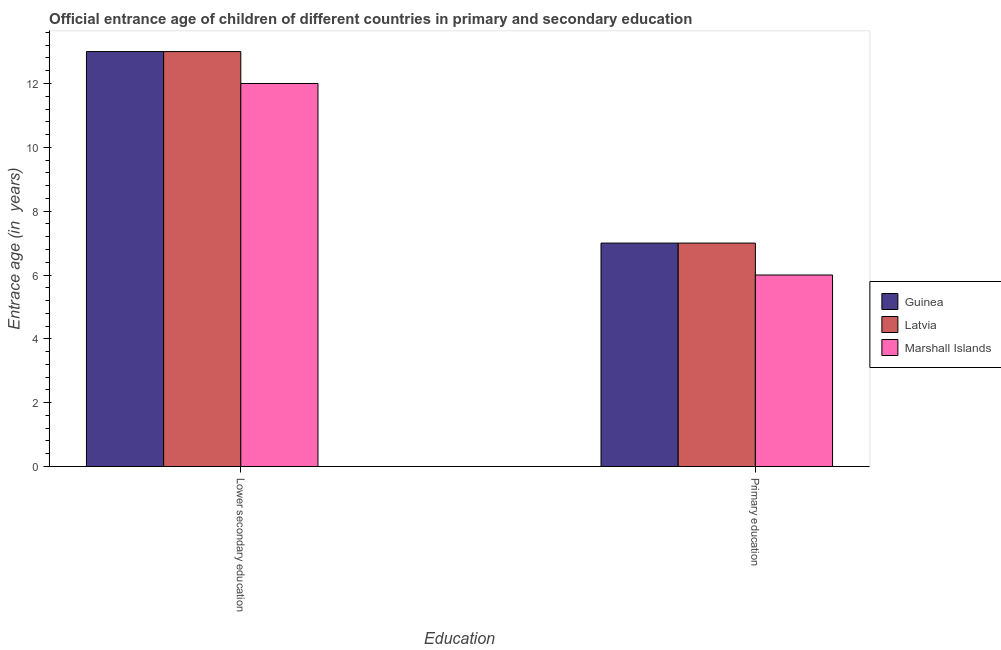How many different coloured bars are there?
Ensure brevity in your answer.  3. Are the number of bars per tick equal to the number of legend labels?
Your answer should be compact. Yes. How many bars are there on the 2nd tick from the left?
Offer a terse response. 3. How many bars are there on the 2nd tick from the right?
Offer a terse response. 3. What is the label of the 2nd group of bars from the left?
Offer a very short reply. Primary education. What is the entrance age of chiildren in primary education in Guinea?
Your answer should be compact. 7. Across all countries, what is the maximum entrance age of children in lower secondary education?
Give a very brief answer. 13. Across all countries, what is the minimum entrance age of chiildren in primary education?
Make the answer very short. 6. In which country was the entrance age of children in lower secondary education maximum?
Give a very brief answer. Guinea. In which country was the entrance age of children in lower secondary education minimum?
Keep it short and to the point. Marshall Islands. What is the total entrance age of children in lower secondary education in the graph?
Ensure brevity in your answer.  38. What is the difference between the entrance age of children in lower secondary education in Latvia and that in Guinea?
Your answer should be very brief. 0. What is the difference between the entrance age of chiildren in primary education in Marshall Islands and the entrance age of children in lower secondary education in Guinea?
Make the answer very short. -7. What is the average entrance age of children in lower secondary education per country?
Provide a short and direct response. 12.67. What is the difference between the entrance age of chiildren in primary education and entrance age of children in lower secondary education in Guinea?
Make the answer very short. -6. What is the ratio of the entrance age of chiildren in primary education in Latvia to that in Marshall Islands?
Your response must be concise. 1.17. Is the entrance age of chiildren in primary education in Marshall Islands less than that in Guinea?
Make the answer very short. Yes. What does the 1st bar from the left in Primary education represents?
Offer a terse response. Guinea. What does the 3rd bar from the right in Primary education represents?
Offer a very short reply. Guinea. How many bars are there?
Offer a very short reply. 6. Are all the bars in the graph horizontal?
Provide a succinct answer. No. What is the difference between two consecutive major ticks on the Y-axis?
Your response must be concise. 2. Does the graph contain grids?
Your response must be concise. No. How many legend labels are there?
Provide a short and direct response. 3. How are the legend labels stacked?
Offer a very short reply. Vertical. What is the title of the graph?
Your answer should be compact. Official entrance age of children of different countries in primary and secondary education. What is the label or title of the X-axis?
Your response must be concise. Education. What is the label or title of the Y-axis?
Your answer should be very brief. Entrace age (in  years). What is the Entrace age (in  years) of Guinea in Lower secondary education?
Keep it short and to the point. 13. What is the Entrace age (in  years) of Marshall Islands in Lower secondary education?
Keep it short and to the point. 12. What is the Entrace age (in  years) in Marshall Islands in Primary education?
Keep it short and to the point. 6. Across all Education, what is the maximum Entrace age (in  years) of Latvia?
Offer a terse response. 13. Across all Education, what is the minimum Entrace age (in  years) in Latvia?
Your response must be concise. 7. Across all Education, what is the minimum Entrace age (in  years) in Marshall Islands?
Your response must be concise. 6. What is the total Entrace age (in  years) of Latvia in the graph?
Your answer should be very brief. 20. What is the total Entrace age (in  years) in Marshall Islands in the graph?
Give a very brief answer. 18. What is the difference between the Entrace age (in  years) of Guinea in Lower secondary education and that in Primary education?
Provide a succinct answer. 6. What is the difference between the Entrace age (in  years) of Marshall Islands in Lower secondary education and that in Primary education?
Your answer should be very brief. 6. What is the difference between the Entrace age (in  years) of Guinea in Lower secondary education and the Entrace age (in  years) of Latvia in Primary education?
Your response must be concise. 6. What is the difference between the Entrace age (in  years) of Guinea in Lower secondary education and the Entrace age (in  years) of Marshall Islands in Primary education?
Make the answer very short. 7. What is the average Entrace age (in  years) of Guinea per Education?
Offer a very short reply. 10. What is the average Entrace age (in  years) in Latvia per Education?
Your answer should be very brief. 10. What is the average Entrace age (in  years) of Marshall Islands per Education?
Make the answer very short. 9. What is the difference between the Entrace age (in  years) of Guinea and Entrace age (in  years) of Latvia in Lower secondary education?
Keep it short and to the point. 0. What is the difference between the Entrace age (in  years) of Guinea and Entrace age (in  years) of Marshall Islands in Lower secondary education?
Give a very brief answer. 1. What is the difference between the Entrace age (in  years) in Latvia and Entrace age (in  years) in Marshall Islands in Lower secondary education?
Keep it short and to the point. 1. What is the difference between the Entrace age (in  years) of Guinea and Entrace age (in  years) of Marshall Islands in Primary education?
Provide a short and direct response. 1. What is the ratio of the Entrace age (in  years) of Guinea in Lower secondary education to that in Primary education?
Your answer should be compact. 1.86. What is the ratio of the Entrace age (in  years) of Latvia in Lower secondary education to that in Primary education?
Provide a succinct answer. 1.86. What is the ratio of the Entrace age (in  years) in Marshall Islands in Lower secondary education to that in Primary education?
Make the answer very short. 2. What is the difference between the highest and the second highest Entrace age (in  years) in Marshall Islands?
Offer a very short reply. 6. What is the difference between the highest and the lowest Entrace age (in  years) of Guinea?
Provide a succinct answer. 6. What is the difference between the highest and the lowest Entrace age (in  years) in Marshall Islands?
Make the answer very short. 6. 